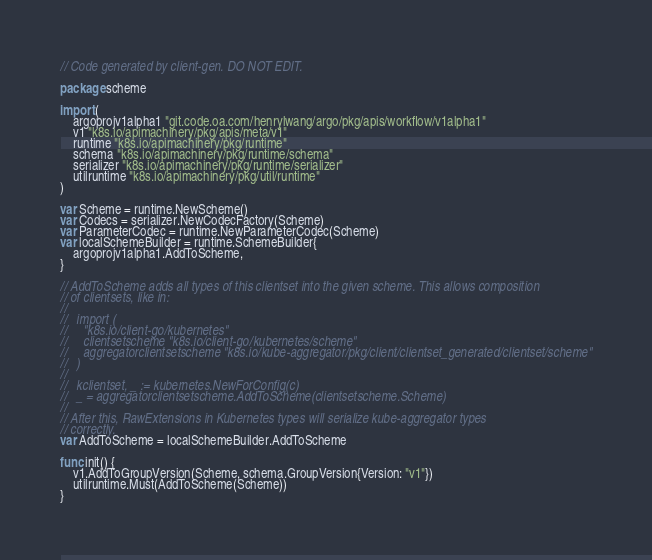Convert code to text. <code><loc_0><loc_0><loc_500><loc_500><_Go_>// Code generated by client-gen. DO NOT EDIT.

package scheme

import (
	argoprojv1alpha1 "git.code.oa.com/henrylwang/argo/pkg/apis/workflow/v1alpha1"
	v1 "k8s.io/apimachinery/pkg/apis/meta/v1"
	runtime "k8s.io/apimachinery/pkg/runtime"
	schema "k8s.io/apimachinery/pkg/runtime/schema"
	serializer "k8s.io/apimachinery/pkg/runtime/serializer"
	utilruntime "k8s.io/apimachinery/pkg/util/runtime"
)

var Scheme = runtime.NewScheme()
var Codecs = serializer.NewCodecFactory(Scheme)
var ParameterCodec = runtime.NewParameterCodec(Scheme)
var localSchemeBuilder = runtime.SchemeBuilder{
	argoprojv1alpha1.AddToScheme,
}

// AddToScheme adds all types of this clientset into the given scheme. This allows composition
// of clientsets, like in:
//
//   import (
//     "k8s.io/client-go/kubernetes"
//     clientsetscheme "k8s.io/client-go/kubernetes/scheme"
//     aggregatorclientsetscheme "k8s.io/kube-aggregator/pkg/client/clientset_generated/clientset/scheme"
//   )
//
//   kclientset, _ := kubernetes.NewForConfig(c)
//   _ = aggregatorclientsetscheme.AddToScheme(clientsetscheme.Scheme)
//
// After this, RawExtensions in Kubernetes types will serialize kube-aggregator types
// correctly.
var AddToScheme = localSchemeBuilder.AddToScheme

func init() {
	v1.AddToGroupVersion(Scheme, schema.GroupVersion{Version: "v1"})
	utilruntime.Must(AddToScheme(Scheme))
}
</code> 